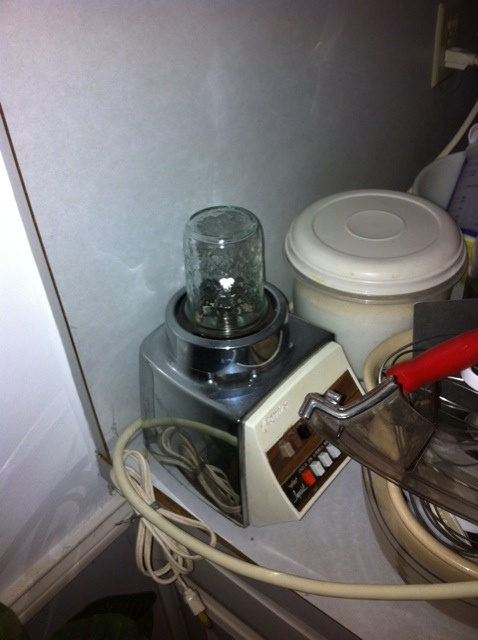Describe the objects in this image and their specific colors. I can see a cup in darkgray, gray, and black tones in this image. 